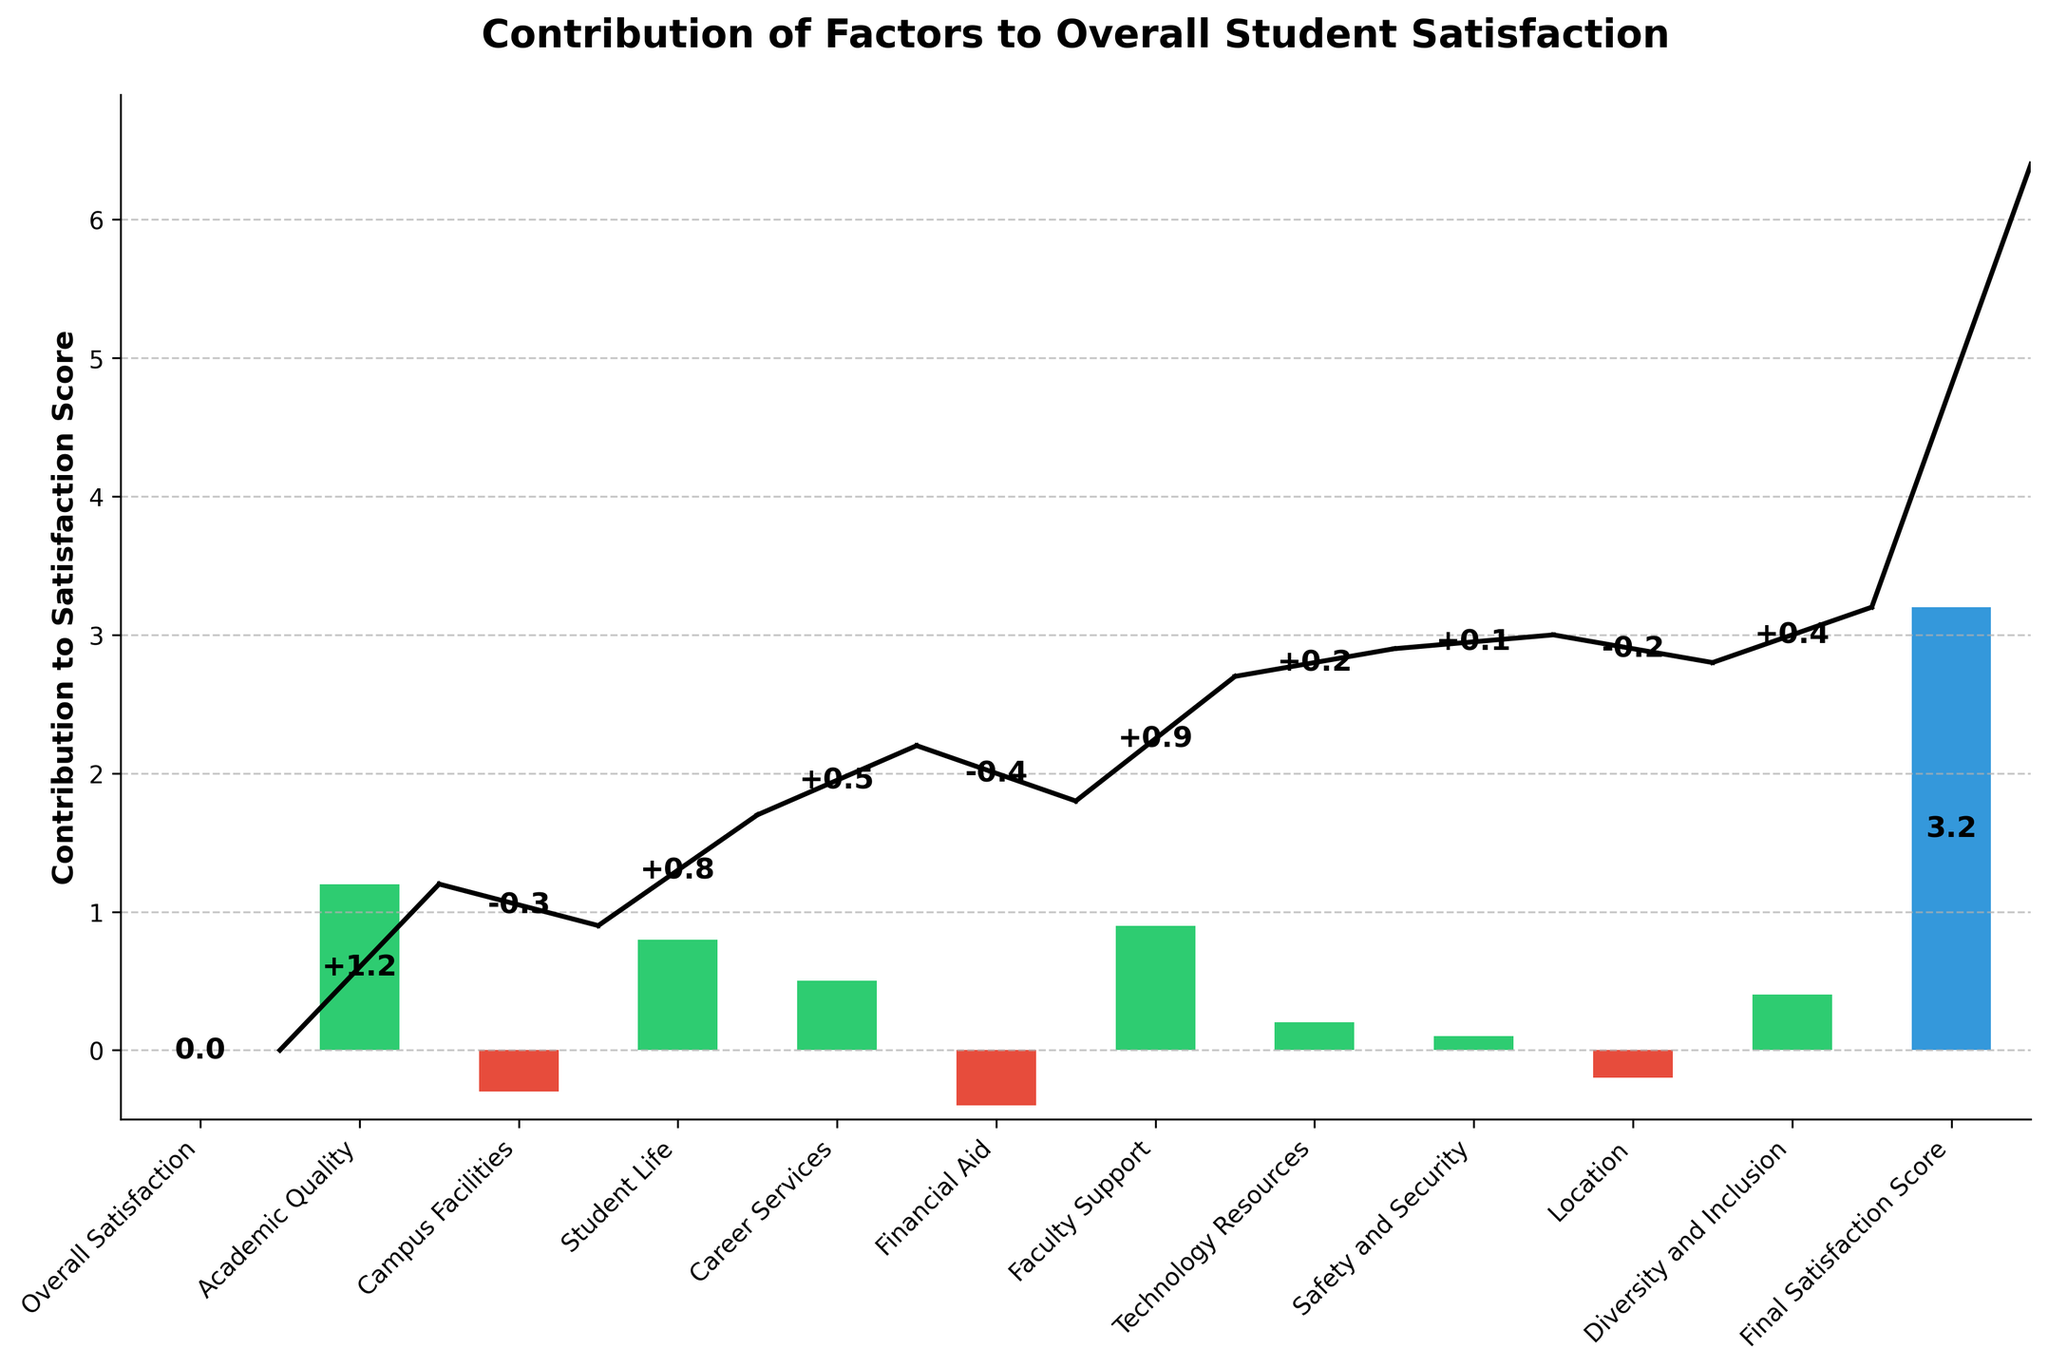What is the final satisfaction score indicated in the chart? The final satisfaction score can be identified by looking at the last bar in the chart labeled "Final Satisfaction Score." This bar shows the cumulative impact of all factors.
Answer: 3.2 Which factor has the highest positive contribution to student satisfaction? The highest positive contribution is the bar with the longest height in the positive direction. By comparing the bars, the "Academic Quality" with a contribution of +1.2 is the highest positive contributor.
Answer: Academic Quality Which factor has the highest negative contribution to student satisfaction? The highest negative contribution is the bar that extends the longest in the negative direction. "Campus Facilities" shows the most significant negative contribution with -0.3.
Answer: Campus Facilities How many factors contributed positively to student satisfaction? Count the number of bars extending in the positive direction. The factors with positive contributions are "Academic Quality," "Student Life," "Career Services," "Faculty Support," "Technology Resources," "Safety and Security," and "Diversity and Inclusion."
Answer: 7 What is the combined contribution of "Financial Aid" and "Location" to the overall satisfaction? Add the contributions of both "Financial Aid" (-0.4) and "Location" (-0.2). (-0.4) + (-0.2) = -0.6
Answer: -0.6 Which factors contributed less than +0.2 to student satisfaction? Identify the bars with contributions less than +0.2. Both "Safety and Security" (+0.1) and "Technology Resources" (+0.2) fall into this category.
Answer: Safety and Security, Technology Resources What is the total positive contribution from all factors? Add all the positive contribution values: +1.2 (Academic Quality) + 0.8 (Student Life) + 0.5 (Career Services) + 0.9 (Faculty Support) + 0.2 (Technology Resources) + 0.1 (Safety and Security) + 0.4 (Diversity and Inclusion). The total is 4.1
Answer: 4.1 What is the cumulative contribution to satisfaction before and after accounting for "Campus Facilities"? The cumulative impact before adjusting for "Campus Facilities" is from just "Academic Quality" which is +1.2. After adding the impact of "Campus Facilities," it's +1.2 - 0.3 = +0.9.
Answer: Before: +1.2, After: +0.9 Which factors have a positive contribution but less than the average contribution of all factors? Calculate the average then identify factors. Average contribution = Total sum / Number of factors excluding 'Overall Satisfaction' and 'Final Satisfaction Score' which is (1.2 - 0.3 + 0.8 + 0.5 - 0.4 + 0.9 + 0.2 + 0.1 - 0.2 + 0.4) / 10 = 0.32. Factors less than 0.32 but positive are "Career Services" (+0.5 is more), "Technology Resources" (+0.2), and "Safety and Security" (+0.1).
Answer: Technology Resources, Safety and Security 